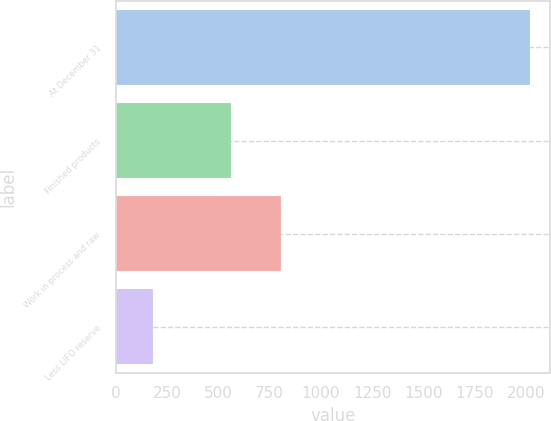Convert chart. <chart><loc_0><loc_0><loc_500><loc_500><bar_chart><fcel>At December 31<fcel>Finished products<fcel>Work in process and raw<fcel>Less LIFO reserve<nl><fcel>2018<fcel>563.2<fcel>803.3<fcel>181.8<nl></chart> 